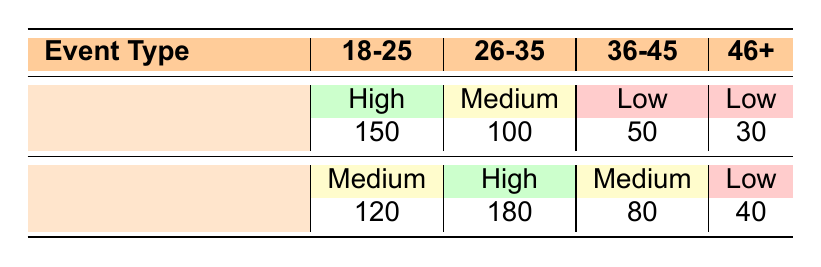What is the total number of responses for local badminton matches? To find the total responses for local badminton matches, we need to sum the responses for all age groups under the "Local Badminton Match" category: 150 + 100 + 50 + 30 = 330.
Answer: 330 Which age group showed the highest interest in local badminton matches? By examining the responses under the "Local Badminton Match" category, we see that the 18-25 age group has 150 responses with a high interest level, which is more than any other age group.
Answer: 18-25 Is there a higher level of interest in international badminton events compared to local matches for the 26-35 age group? For the 26-35 age group, the interest level for local matches is medium with 100 responses, while for international events it is high with 180 responses, indicating a higher interest in international events.
Answer: Yes What percentage of the total responses for international badminton events comes from the 26-35 age group? First, calculate the total responses for international events: 120 + 180 + 80 + 40 = 420. The responses for the 26-35 age group is 180. The percentage is (180/420)*100 = 42.86%.
Answer: 42.86% Which event type has more respondents showing low interest in the 36-45 age group? The local badminton match has 50 low interest responses, while the international badminton event has only 80. Comparing these, the international event has more respondents showing low interest.
Answer: International Badminton Event What is the average interest level for local matches across all age groups? The interest levels in terms of responses are: 150 (High) for 18-25, 100 (Medium) for 26-35, 50 (Low) for 36-45, and 30 (Low) for 46+. Converting these into numeric values (High=3, Medium=2, Low=1): (3*150 + 2*100 + 1*50 + 1*30) / 330 = (450 + 200 + 50 + 30) / 330 = 730 / 330 = 2.21 (Medium).
Answer: Medium Which age group has the least interest in international badminton events based on the given data? Looking at the responses for international events, the 46 and above age group has the least interest with only 40 low interest responses, making it the lowest.
Answer: 46 and above How many total responses are recorded for age groups 18-25 and 26-35 combined for international badminton events? We sum the responses from these age groups under international events: 120 (18-25) + 180 (26-35) = 300.
Answer: 300 Was the interest level for international badminton events higher in the 18-25 age group compared to that of local badminton matches in the same age group? Comparing the responses, the 18-25 age group has 150 high responses for local badminton matches and 120 medium responses for international events, showing higher interest in local matches.
Answer: No 